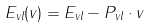Convert formula to latex. <formula><loc_0><loc_0><loc_500><loc_500>E _ { v l } ( v ) = E _ { v l } - { P _ { v l } } \cdot { v }</formula> 